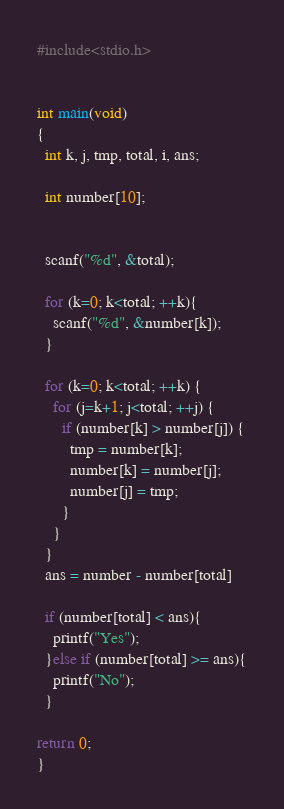Convert code to text. <code><loc_0><loc_0><loc_500><loc_500><_C_>#include<stdio.h>


int main(void)
{
  int k, j, tmp, total, i, ans;

  int number[10];


  scanf("%d", &total);

  for (k=0; k<total; ++k){
    scanf("%d", &number[k]);
  }

  for (k=0; k<total; ++k) {
    for (j=k+1; j<total; ++j) {
      if (number[k] > number[j]) {
        tmp = number[k];
        number[k] = number[j];
        number[j] = tmp;
      }
    }
  }
  ans = number - number[total]

  if (number[total] < ans){
    printf("Yes");
  }else if (number[total] >= ans){
    printf("No");
  }

return 0;
}
</code> 